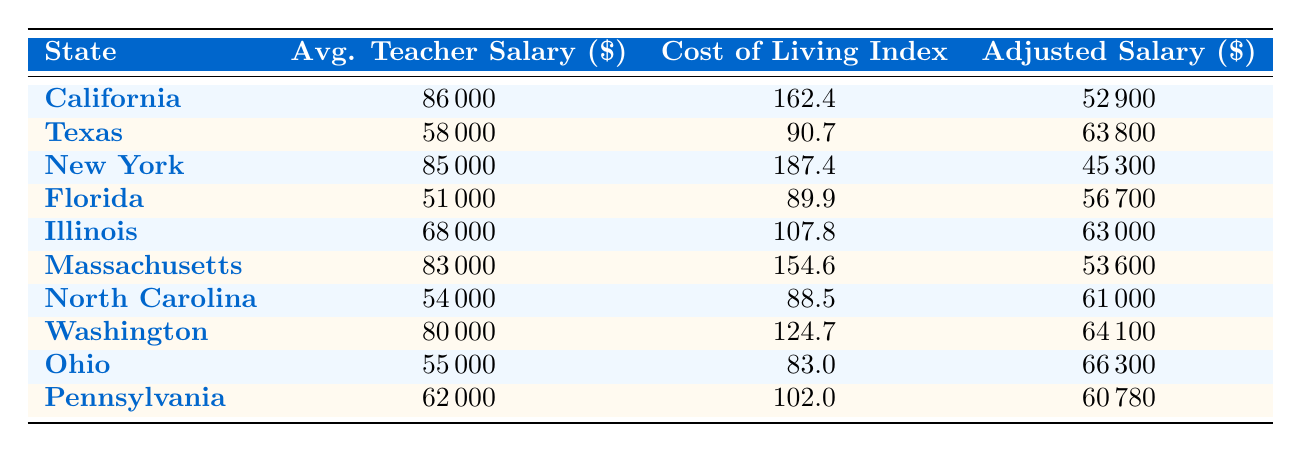What is the average teacher salary in California? The table shows that the average teacher salary in California is listed as 86,000 dollars.
Answer: 86,000 Which state has the lowest adjusted salary for teachers? By examining the adjusted salary values in the table, the lowest is found in New York, which has an adjusted salary of 45,300 dollars.
Answer: New York What is the cost of living index for Florida? The table shows that the cost of living index for Florida is 89.9.
Answer: 89.9 Which state has the highest average teacher salary? California has the highest average teacher salary at 86,000 dollars, as per the table.
Answer: California What is the difference between the adjusted salaries of Illinois and North Carolina? The adjusted salary for Illinois is 63,000 dollars and for North Carolina, it is 61,000 dollars. The difference is 63,000 - 61,000 = 2,000 dollars.
Answer: 2,000 Is the cost of living index in Texas higher than that in North Carolina? The cost of living index in Texas is 90.7, while in North Carolina, it is 88.5. Thus, 90.7 is greater than 88.5, so yes, Texas has a higher index.
Answer: Yes What is the average adjusted salary of all the states listed in the table? Summing the adjusted salaries gives 52,900 (California) + 63,800 (Texas) + 45,300 (New York) + 56,700 (Florida) + 63,000 (Illinois) + 53,600 (Massachusetts) + 61,000 (North Carolina) + 64,100 (Washington) + 66,300 (Ohio) + 60,780 (Pennsylvania) = 10,344,600. Dividing this by 10 (the number of states) gives an average of 1,034,460 and rounding gives an average of 61,900 dollars.
Answer: 61,900 Which states have an adjusted salary above 60,000 dollars? The states with adjusted salaries above 60,000 dollars are Texas (63,800), Illinois (63,000), Washington (64,100), and Ohio (66,300).
Answer: Texas, Illinois, Washington, Ohio What is the overall trend in teacher salaries compared to the cost of living across the states? A comparative analysis shows that states with higher average teacher salaries (like California and New York) also have high cost of living indexes, but their adjusted salaries are comparatively lower, indicating that while salaries may appear high, the cost of living significantly impacts the real income available for teachers.
Answer: High salaries in expensive states lead to lower adjusted salaries 